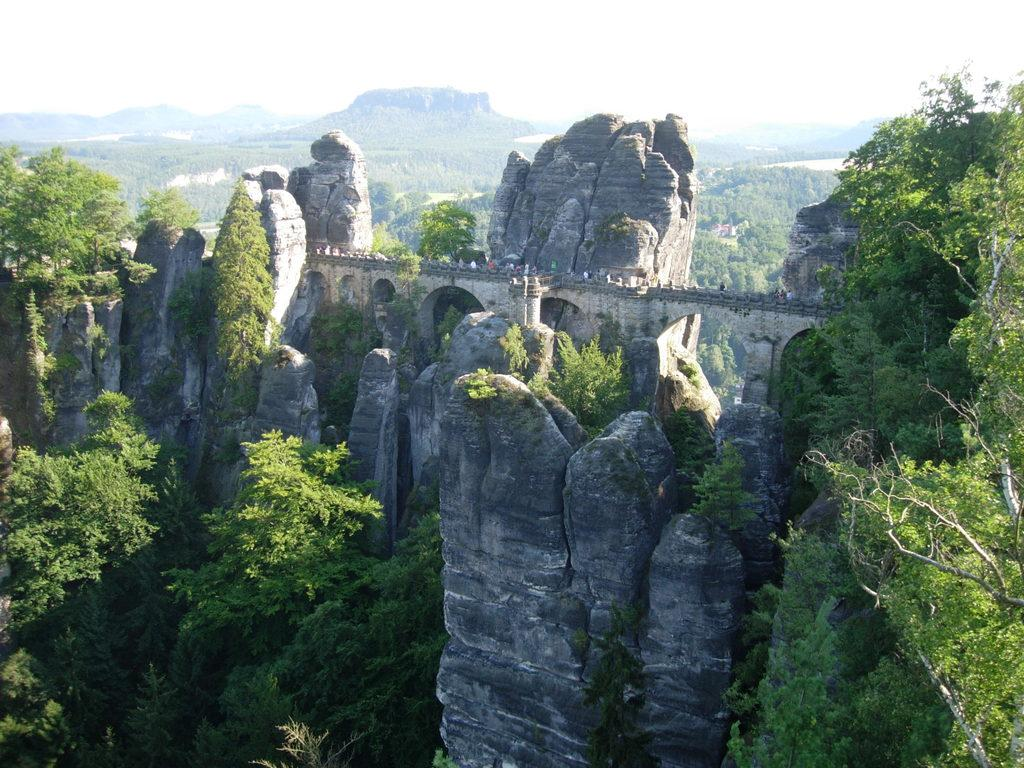What type of natural elements can be seen in the image? There are rocks and trees in the image. What type of landscape feature is visible in the background of the image? There are mountains in the background of the image. What is the color of the sky in the image? The sky is white in the image. Where are the flowers located in the image? There are no flowers present in the image. 